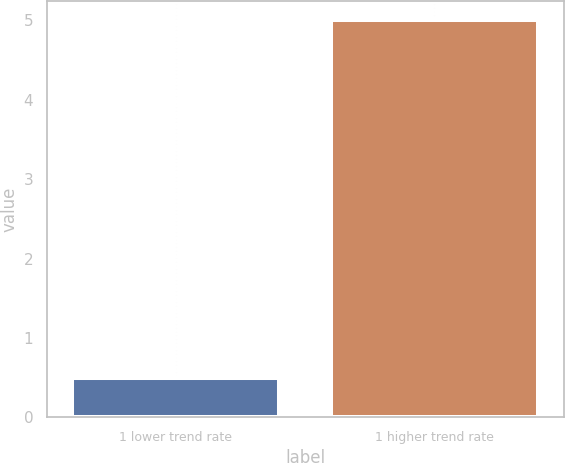<chart> <loc_0><loc_0><loc_500><loc_500><bar_chart><fcel>1 lower trend rate<fcel>1 higher trend rate<nl><fcel>0.5<fcel>5<nl></chart> 